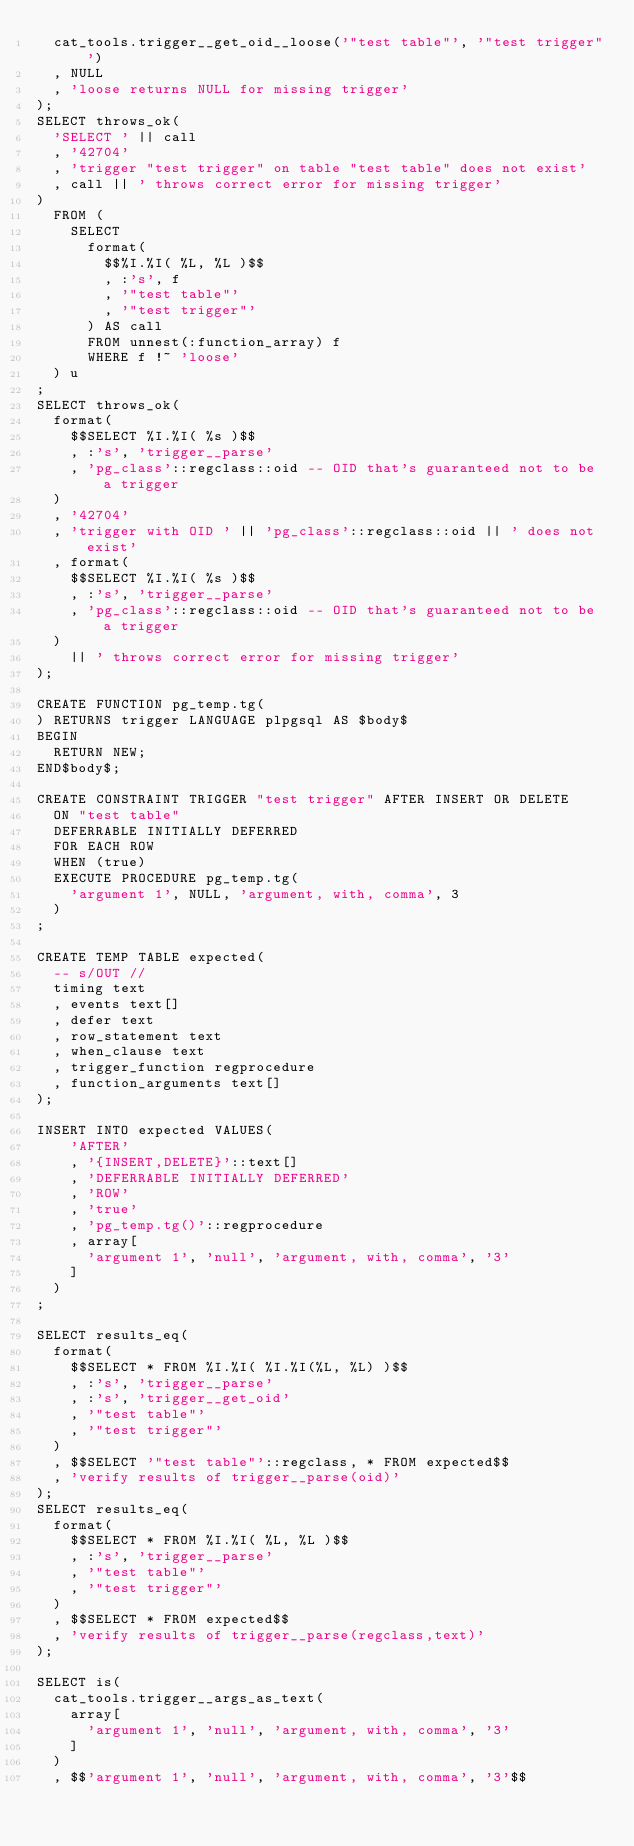Convert code to text. <code><loc_0><loc_0><loc_500><loc_500><_SQL_>  cat_tools.trigger__get_oid__loose('"test table"', '"test trigger"')
  , NULL
  , 'loose returns NULL for missing trigger'
);
SELECT throws_ok(
  'SELECT ' || call
  , '42704'
  , 'trigger "test trigger" on table "test table" does not exist'
  , call || ' throws correct error for missing trigger'
)
  FROM (
    SELECT
      format(
        $$%I.%I( %L, %L )$$
        , :'s', f
        , '"test table"'
        , '"test trigger"'
      ) AS call
      FROM unnest(:function_array) f
      WHERE f !~ 'loose'
  ) u
;
SELECT throws_ok(
  format(
    $$SELECT %I.%I( %s )$$
    , :'s', 'trigger__parse'
    , 'pg_class'::regclass::oid -- OID that's guaranteed not to be a trigger
  )
  , '42704'
  , 'trigger with OID ' || 'pg_class'::regclass::oid || ' does not exist'
  , format(
    $$SELECT %I.%I( %s )$$
    , :'s', 'trigger__parse'
    , 'pg_class'::regclass::oid -- OID that's guaranteed not to be a trigger
  )
    || ' throws correct error for missing trigger'
);

CREATE FUNCTION pg_temp.tg(
) RETURNS trigger LANGUAGE plpgsql AS $body$
BEGIN
  RETURN NEW;
END$body$;

CREATE CONSTRAINT TRIGGER "test trigger" AFTER INSERT OR DELETE
  ON "test table"
  DEFERRABLE INITIALLY DEFERRED
  FOR EACH ROW
  WHEN (true)
  EXECUTE PROCEDURE pg_temp.tg(
    'argument 1', NULL, 'argument, with, comma', 3
  )
;

CREATE TEMP TABLE expected(
  -- s/OUT //
  timing text
  , events text[]
  , defer text
  , row_statement text
  , when_clause text
  , trigger_function regprocedure
  , function_arguments text[]
);

INSERT INTO expected VALUES(
    'AFTER'
    , '{INSERT,DELETE}'::text[]
    , 'DEFERRABLE INITIALLY DEFERRED'
    , 'ROW'
    , 'true'
    , 'pg_temp.tg()'::regprocedure
    , array[
      'argument 1', 'null', 'argument, with, comma', '3'
    ]
  )
;

SELECT results_eq(
  format(
    $$SELECT * FROM %I.%I( %I.%I(%L, %L) )$$
    , :'s', 'trigger__parse'
    , :'s', 'trigger__get_oid'
    , '"test table"'
    , '"test trigger"'
  )
  , $$SELECT '"test table"'::regclass, * FROM expected$$
  , 'verify results of trigger__parse(oid)'
);
SELECT results_eq(
  format(
    $$SELECT * FROM %I.%I( %L, %L )$$
    , :'s', 'trigger__parse'
    , '"test table"'
    , '"test trigger"'
  )
  , $$SELECT * FROM expected$$
  , 'verify results of trigger__parse(regclass,text)'
);

SELECT is(
  cat_tools.trigger__args_as_text(
    array[
      'argument 1', 'null', 'argument, with, comma', '3'
    ]
  )
  , $$'argument 1', 'null', 'argument, with, comma', '3'$$</code> 